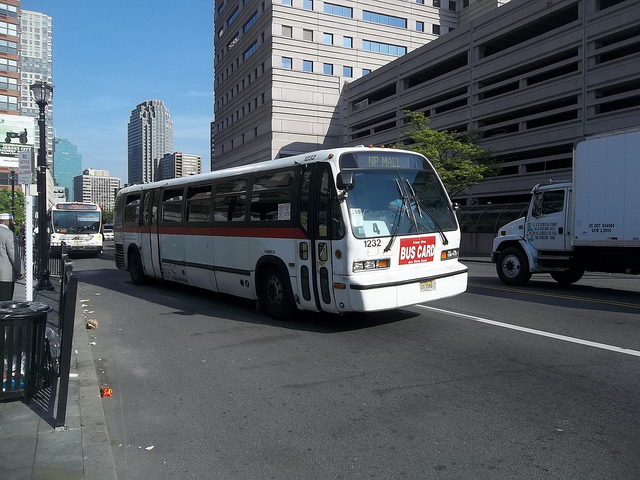<image>What is the bus company's name? I don't know the bus company's name. It could be 'metro', 'np mall', 'bus card', or 'mbta'. Where are the traffic cones? There are no traffic cones in the image. However, they could be on the road, sidewalk, in storage or on the bus. Where are the traffic cones? It is not clear where the traffic cones are. They are not visible in the image. What is the bus company's name? I don't know what is the bus company's name, but it can be seen 'metro', 'np mall', 'bus card' or 'mbta'. 